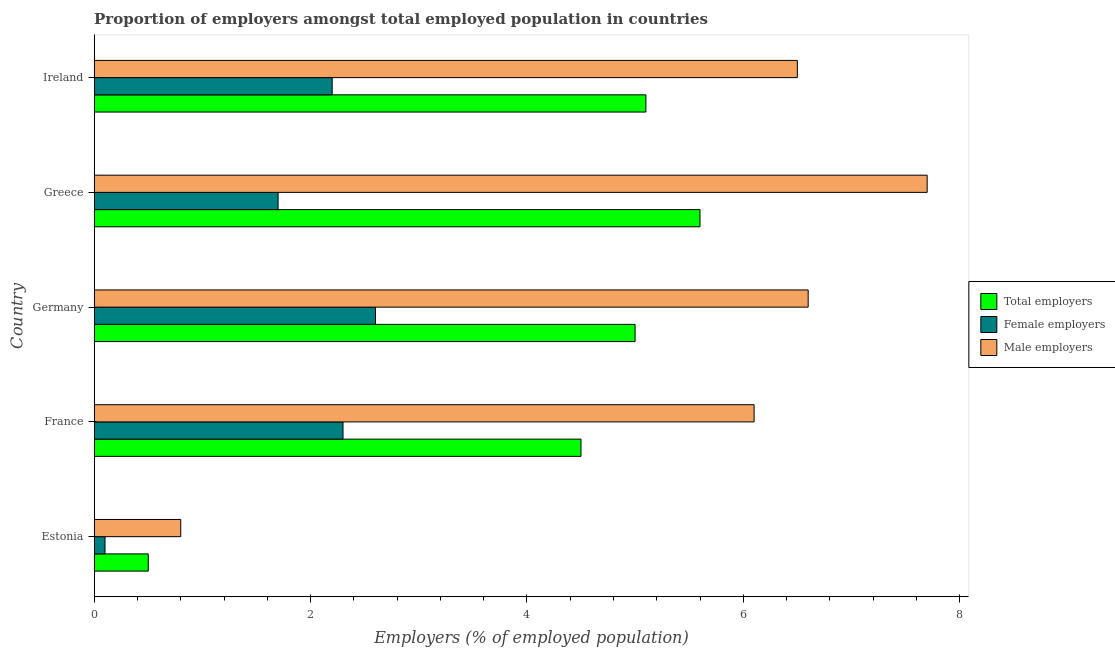Are the number of bars per tick equal to the number of legend labels?
Provide a short and direct response. Yes. How many bars are there on the 5th tick from the top?
Make the answer very short. 3. In how many cases, is the number of bars for a given country not equal to the number of legend labels?
Your response must be concise. 0. What is the percentage of male employers in Estonia?
Keep it short and to the point. 0.8. Across all countries, what is the maximum percentage of male employers?
Give a very brief answer. 7.7. Across all countries, what is the minimum percentage of female employers?
Ensure brevity in your answer.  0.1. In which country was the percentage of female employers minimum?
Make the answer very short. Estonia. What is the total percentage of male employers in the graph?
Ensure brevity in your answer.  27.7. What is the difference between the percentage of female employers in Greece and that in Ireland?
Your answer should be compact. -0.5. What is the difference between the percentage of male employers in Greece and the percentage of total employers in Germany?
Your answer should be compact. 2.7. What is the average percentage of total employers per country?
Ensure brevity in your answer.  4.14. In how many countries, is the percentage of total employers greater than 1.6 %?
Give a very brief answer. 4. What is the ratio of the percentage of total employers in France to that in Germany?
Keep it short and to the point. 0.9. Is the difference between the percentage of total employers in Germany and Greece greater than the difference between the percentage of male employers in Germany and Greece?
Make the answer very short. Yes. What is the difference between the highest and the lowest percentage of female employers?
Give a very brief answer. 2.5. In how many countries, is the percentage of total employers greater than the average percentage of total employers taken over all countries?
Provide a succinct answer. 4. What does the 2nd bar from the top in Greece represents?
Provide a short and direct response. Female employers. What does the 2nd bar from the bottom in Ireland represents?
Provide a short and direct response. Female employers. Is it the case that in every country, the sum of the percentage of total employers and percentage of female employers is greater than the percentage of male employers?
Offer a terse response. No. Are all the bars in the graph horizontal?
Make the answer very short. Yes. How many countries are there in the graph?
Keep it short and to the point. 5. What is the difference between two consecutive major ticks on the X-axis?
Offer a very short reply. 2. Are the values on the major ticks of X-axis written in scientific E-notation?
Make the answer very short. No. Does the graph contain any zero values?
Keep it short and to the point. No. Does the graph contain grids?
Your answer should be very brief. No. Where does the legend appear in the graph?
Provide a short and direct response. Center right. How many legend labels are there?
Offer a terse response. 3. What is the title of the graph?
Ensure brevity in your answer.  Proportion of employers amongst total employed population in countries. What is the label or title of the X-axis?
Ensure brevity in your answer.  Employers (% of employed population). What is the Employers (% of employed population) in Female employers in Estonia?
Keep it short and to the point. 0.1. What is the Employers (% of employed population) in Male employers in Estonia?
Provide a succinct answer. 0.8. What is the Employers (% of employed population) of Total employers in France?
Provide a short and direct response. 4.5. What is the Employers (% of employed population) in Female employers in France?
Your answer should be very brief. 2.3. What is the Employers (% of employed population) of Male employers in France?
Your response must be concise. 6.1. What is the Employers (% of employed population) in Female employers in Germany?
Your answer should be very brief. 2.6. What is the Employers (% of employed population) of Male employers in Germany?
Your answer should be very brief. 6.6. What is the Employers (% of employed population) in Total employers in Greece?
Give a very brief answer. 5.6. What is the Employers (% of employed population) of Female employers in Greece?
Provide a short and direct response. 1.7. What is the Employers (% of employed population) of Male employers in Greece?
Provide a succinct answer. 7.7. What is the Employers (% of employed population) of Total employers in Ireland?
Make the answer very short. 5.1. What is the Employers (% of employed population) in Female employers in Ireland?
Your response must be concise. 2.2. What is the Employers (% of employed population) of Male employers in Ireland?
Keep it short and to the point. 6.5. Across all countries, what is the maximum Employers (% of employed population) of Total employers?
Make the answer very short. 5.6. Across all countries, what is the maximum Employers (% of employed population) in Female employers?
Ensure brevity in your answer.  2.6. Across all countries, what is the maximum Employers (% of employed population) in Male employers?
Your answer should be compact. 7.7. Across all countries, what is the minimum Employers (% of employed population) of Female employers?
Provide a short and direct response. 0.1. Across all countries, what is the minimum Employers (% of employed population) of Male employers?
Your answer should be very brief. 0.8. What is the total Employers (% of employed population) in Total employers in the graph?
Provide a short and direct response. 20.7. What is the total Employers (% of employed population) in Female employers in the graph?
Provide a short and direct response. 8.9. What is the total Employers (% of employed population) of Male employers in the graph?
Your response must be concise. 27.7. What is the difference between the Employers (% of employed population) of Female employers in Estonia and that in France?
Provide a succinct answer. -2.2. What is the difference between the Employers (% of employed population) of Male employers in Estonia and that in France?
Provide a succinct answer. -5.3. What is the difference between the Employers (% of employed population) in Total employers in Estonia and that in Germany?
Give a very brief answer. -4.5. What is the difference between the Employers (% of employed population) in Female employers in Estonia and that in Germany?
Your answer should be very brief. -2.5. What is the difference between the Employers (% of employed population) in Total employers in Estonia and that in Ireland?
Ensure brevity in your answer.  -4.6. What is the difference between the Employers (% of employed population) of Female employers in Estonia and that in Ireland?
Make the answer very short. -2.1. What is the difference between the Employers (% of employed population) of Female employers in France and that in Germany?
Ensure brevity in your answer.  -0.3. What is the difference between the Employers (% of employed population) in Female employers in France and that in Greece?
Make the answer very short. 0.6. What is the difference between the Employers (% of employed population) in Male employers in France and that in Greece?
Provide a short and direct response. -1.6. What is the difference between the Employers (% of employed population) of Female employers in France and that in Ireland?
Provide a short and direct response. 0.1. What is the difference between the Employers (% of employed population) in Female employers in Germany and that in Greece?
Ensure brevity in your answer.  0.9. What is the difference between the Employers (% of employed population) in Male employers in Germany and that in Greece?
Your response must be concise. -1.1. What is the difference between the Employers (% of employed population) in Total employers in Germany and that in Ireland?
Make the answer very short. -0.1. What is the difference between the Employers (% of employed population) in Female employers in Germany and that in Ireland?
Keep it short and to the point. 0.4. What is the difference between the Employers (% of employed population) of Male employers in Germany and that in Ireland?
Provide a short and direct response. 0.1. What is the difference between the Employers (% of employed population) in Total employers in Estonia and the Employers (% of employed population) in Female employers in France?
Your answer should be very brief. -1.8. What is the difference between the Employers (% of employed population) of Total employers in Estonia and the Employers (% of employed population) of Female employers in Germany?
Provide a short and direct response. -2.1. What is the difference between the Employers (% of employed population) of Total employers in Estonia and the Employers (% of employed population) of Male employers in Germany?
Make the answer very short. -6.1. What is the difference between the Employers (% of employed population) of Female employers in Estonia and the Employers (% of employed population) of Male employers in Germany?
Ensure brevity in your answer.  -6.5. What is the difference between the Employers (% of employed population) of Total employers in Estonia and the Employers (% of employed population) of Female employers in Greece?
Provide a succinct answer. -1.2. What is the difference between the Employers (% of employed population) of Female employers in Estonia and the Employers (% of employed population) of Male employers in Greece?
Make the answer very short. -7.6. What is the difference between the Employers (% of employed population) in Total employers in France and the Employers (% of employed population) in Female employers in Germany?
Offer a terse response. 1.9. What is the difference between the Employers (% of employed population) of Female employers in France and the Employers (% of employed population) of Male employers in Germany?
Your response must be concise. -4.3. What is the difference between the Employers (% of employed population) in Total employers in France and the Employers (% of employed population) in Male employers in Greece?
Offer a very short reply. -3.2. What is the difference between the Employers (% of employed population) of Total employers in France and the Employers (% of employed population) of Male employers in Ireland?
Provide a short and direct response. -2. What is the difference between the Employers (% of employed population) of Total employers in Germany and the Employers (% of employed population) of Male employers in Greece?
Make the answer very short. -2.7. What is the difference between the Employers (% of employed population) in Female employers in Germany and the Employers (% of employed population) in Male employers in Greece?
Provide a succinct answer. -5.1. What is the difference between the Employers (% of employed population) of Total employers in Germany and the Employers (% of employed population) of Male employers in Ireland?
Provide a short and direct response. -1.5. What is the difference between the Employers (% of employed population) in Female employers in Germany and the Employers (% of employed population) in Male employers in Ireland?
Your response must be concise. -3.9. What is the difference between the Employers (% of employed population) in Total employers in Greece and the Employers (% of employed population) in Female employers in Ireland?
Your response must be concise. 3.4. What is the difference between the Employers (% of employed population) in Female employers in Greece and the Employers (% of employed population) in Male employers in Ireland?
Keep it short and to the point. -4.8. What is the average Employers (% of employed population) in Total employers per country?
Provide a short and direct response. 4.14. What is the average Employers (% of employed population) in Female employers per country?
Make the answer very short. 1.78. What is the average Employers (% of employed population) of Male employers per country?
Keep it short and to the point. 5.54. What is the difference between the Employers (% of employed population) of Total employers and Employers (% of employed population) of Female employers in Estonia?
Ensure brevity in your answer.  0.4. What is the difference between the Employers (% of employed population) of Total employers and Employers (% of employed population) of Male employers in Estonia?
Keep it short and to the point. -0.3. What is the difference between the Employers (% of employed population) in Total employers and Employers (% of employed population) in Female employers in France?
Make the answer very short. 2.2. What is the difference between the Employers (% of employed population) of Total employers and Employers (% of employed population) of Female employers in Germany?
Keep it short and to the point. 2.4. What is the difference between the Employers (% of employed population) of Total employers and Employers (% of employed population) of Male employers in Germany?
Make the answer very short. -1.6. What is the difference between the Employers (% of employed population) of Female employers and Employers (% of employed population) of Male employers in Germany?
Provide a short and direct response. -4. What is the difference between the Employers (% of employed population) of Total employers and Employers (% of employed population) of Female employers in Greece?
Your answer should be very brief. 3.9. What is the difference between the Employers (% of employed population) in Total employers and Employers (% of employed population) in Male employers in Greece?
Your response must be concise. -2.1. What is the ratio of the Employers (% of employed population) in Female employers in Estonia to that in France?
Keep it short and to the point. 0.04. What is the ratio of the Employers (% of employed population) in Male employers in Estonia to that in France?
Make the answer very short. 0.13. What is the ratio of the Employers (% of employed population) in Total employers in Estonia to that in Germany?
Make the answer very short. 0.1. What is the ratio of the Employers (% of employed population) of Female employers in Estonia to that in Germany?
Offer a very short reply. 0.04. What is the ratio of the Employers (% of employed population) of Male employers in Estonia to that in Germany?
Offer a very short reply. 0.12. What is the ratio of the Employers (% of employed population) in Total employers in Estonia to that in Greece?
Keep it short and to the point. 0.09. What is the ratio of the Employers (% of employed population) in Female employers in Estonia to that in Greece?
Your answer should be compact. 0.06. What is the ratio of the Employers (% of employed population) in Male employers in Estonia to that in Greece?
Give a very brief answer. 0.1. What is the ratio of the Employers (% of employed population) in Total employers in Estonia to that in Ireland?
Offer a very short reply. 0.1. What is the ratio of the Employers (% of employed population) of Female employers in Estonia to that in Ireland?
Your response must be concise. 0.05. What is the ratio of the Employers (% of employed population) of Male employers in Estonia to that in Ireland?
Provide a short and direct response. 0.12. What is the ratio of the Employers (% of employed population) of Female employers in France to that in Germany?
Provide a succinct answer. 0.88. What is the ratio of the Employers (% of employed population) in Male employers in France to that in Germany?
Give a very brief answer. 0.92. What is the ratio of the Employers (% of employed population) of Total employers in France to that in Greece?
Offer a terse response. 0.8. What is the ratio of the Employers (% of employed population) of Female employers in France to that in Greece?
Provide a succinct answer. 1.35. What is the ratio of the Employers (% of employed population) of Male employers in France to that in Greece?
Offer a terse response. 0.79. What is the ratio of the Employers (% of employed population) of Total employers in France to that in Ireland?
Offer a terse response. 0.88. What is the ratio of the Employers (% of employed population) of Female employers in France to that in Ireland?
Offer a terse response. 1.05. What is the ratio of the Employers (% of employed population) of Male employers in France to that in Ireland?
Your answer should be very brief. 0.94. What is the ratio of the Employers (% of employed population) of Total employers in Germany to that in Greece?
Your answer should be compact. 0.89. What is the ratio of the Employers (% of employed population) of Female employers in Germany to that in Greece?
Your answer should be very brief. 1.53. What is the ratio of the Employers (% of employed population) in Total employers in Germany to that in Ireland?
Your answer should be very brief. 0.98. What is the ratio of the Employers (% of employed population) of Female employers in Germany to that in Ireland?
Ensure brevity in your answer.  1.18. What is the ratio of the Employers (% of employed population) in Male employers in Germany to that in Ireland?
Ensure brevity in your answer.  1.02. What is the ratio of the Employers (% of employed population) in Total employers in Greece to that in Ireland?
Give a very brief answer. 1.1. What is the ratio of the Employers (% of employed population) of Female employers in Greece to that in Ireland?
Your answer should be very brief. 0.77. What is the ratio of the Employers (% of employed population) of Male employers in Greece to that in Ireland?
Your answer should be very brief. 1.18. What is the difference between the highest and the lowest Employers (% of employed population) in Total employers?
Keep it short and to the point. 5.1. What is the difference between the highest and the lowest Employers (% of employed population) of Male employers?
Ensure brevity in your answer.  6.9. 